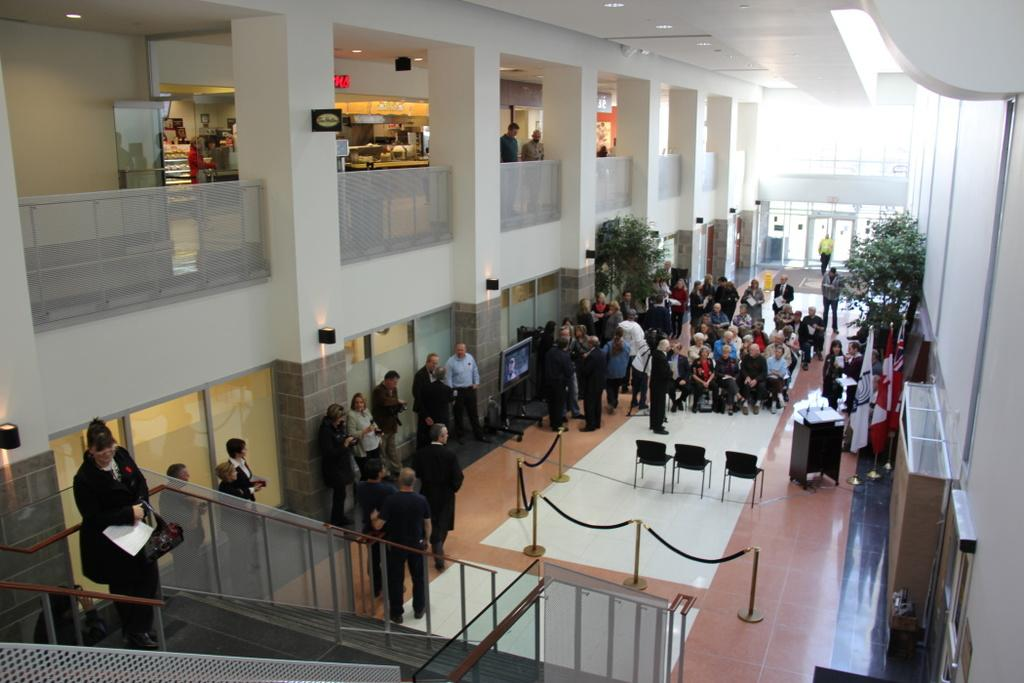Who is present in the image? There are people in the image. Where are the people located? The people are at a shopping mall. How many floors are in the shopping mall? The shopping mall has two floors. What are some features of the building in the image? There is a door and a window in the image. How much money do the people have in the image? There is no information about money in the image. --- Facts: 1. There is a car in the image. 2. The car is red. 3. The car has four wheels. 4. There is a person standing next to the car. 5. The person is holding a phone. Absurd Topics: elephant, ocean, mountain Conversation: What is the main subject in the image? There is a car in the image. Can you describe the car? The car is red. How many wheels does the car have? The car has four wheels. Who or what is present next to the car? There is a person standing next to the car. What is the person doing? The person is holding a phone. Reasoning: Let's think step by step in order to produce the conversation. We start by identifying the main subject of the image, which is the car. Next, we describe specific features of the car, such as its color and the number of wheels it has. Then, we observe the actions of the person in the image, noting that they are holding a phone. Finally, we ensure that the language is simple and clear. Absurd Question/Answer: Can you see any elephants or oceans in the image? There are no elephants or oceans present in the image. 